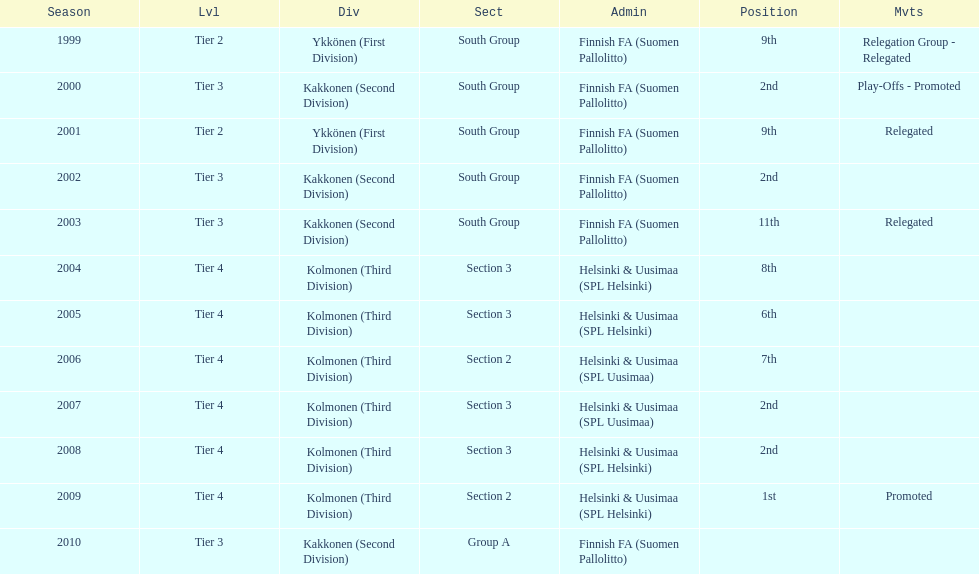Which kolmonen was the only one to have its movements promoted? 2009. 